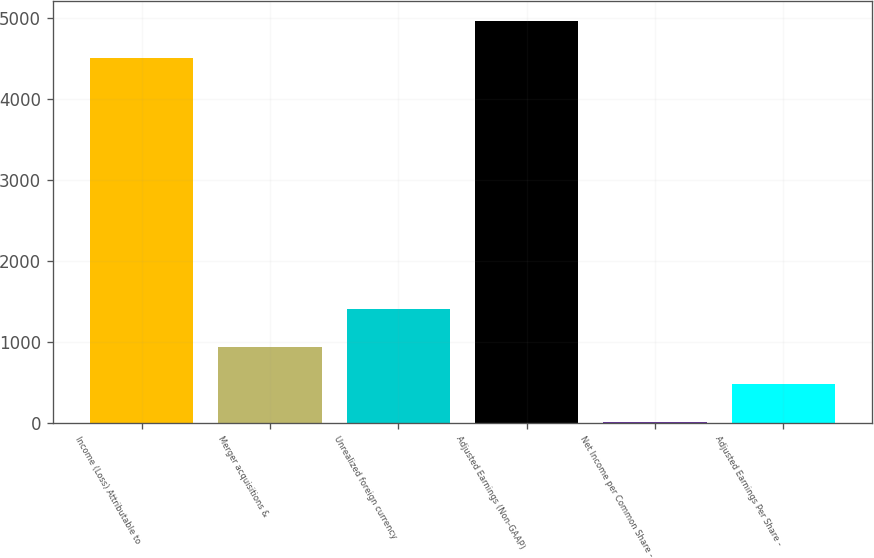Convert chart. <chart><loc_0><loc_0><loc_500><loc_500><bar_chart><fcel>Income (Loss) Attributable to<fcel>Merger acquisitions &<fcel>Unrealized foreign currency<fcel>Adjusted Earnings (Non-GAAP)<fcel>Net Income per Common Share -<fcel>Adjusted Earnings Per Share -<nl><fcel>4508<fcel>939.37<fcel>1403.32<fcel>4971.95<fcel>11.47<fcel>475.42<nl></chart> 